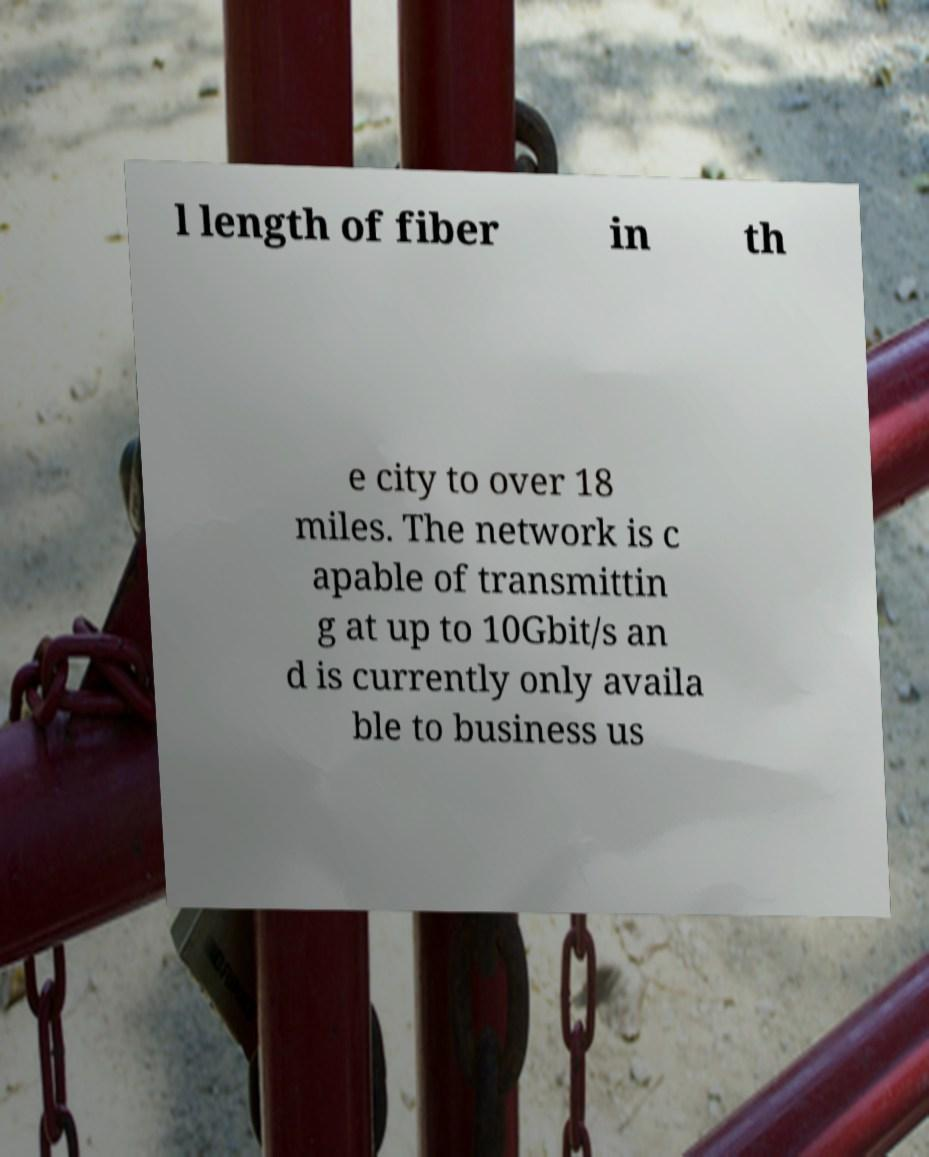For documentation purposes, I need the text within this image transcribed. Could you provide that? l length of fiber in th e city to over 18 miles. The network is c apable of transmittin g at up to 10Gbit/s an d is currently only availa ble to business us 